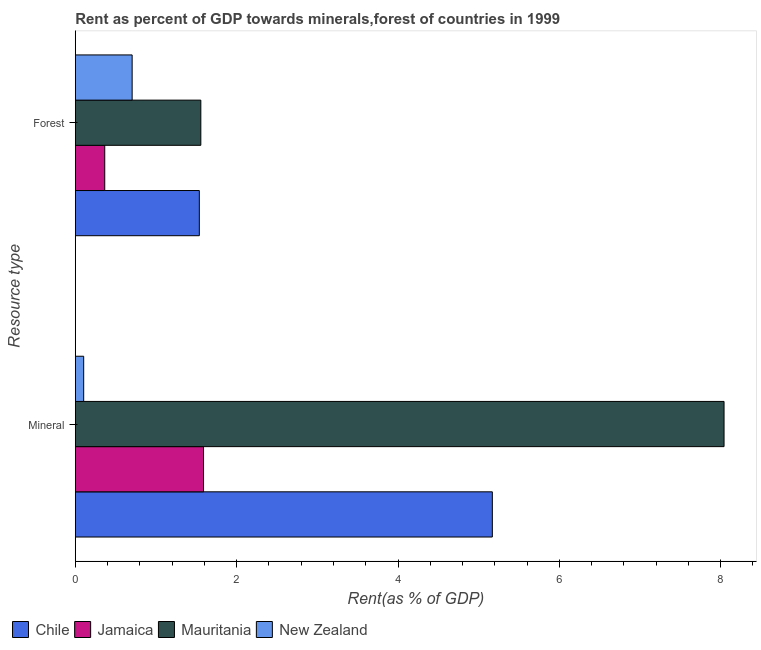How many different coloured bars are there?
Offer a very short reply. 4. How many groups of bars are there?
Give a very brief answer. 2. How many bars are there on the 1st tick from the top?
Provide a short and direct response. 4. How many bars are there on the 1st tick from the bottom?
Give a very brief answer. 4. What is the label of the 1st group of bars from the top?
Ensure brevity in your answer.  Forest. What is the mineral rent in Jamaica?
Offer a very short reply. 1.59. Across all countries, what is the maximum forest rent?
Your answer should be very brief. 1.56. Across all countries, what is the minimum forest rent?
Keep it short and to the point. 0.37. In which country was the forest rent maximum?
Offer a very short reply. Mauritania. In which country was the forest rent minimum?
Give a very brief answer. Jamaica. What is the total mineral rent in the graph?
Your answer should be very brief. 14.9. What is the difference between the forest rent in Mauritania and that in New Zealand?
Your answer should be compact. 0.85. What is the difference between the forest rent in Mauritania and the mineral rent in Jamaica?
Your response must be concise. -0.03. What is the average forest rent per country?
Provide a short and direct response. 1.04. What is the difference between the forest rent and mineral rent in Jamaica?
Give a very brief answer. -1.22. In how many countries, is the mineral rent greater than 0.4 %?
Your answer should be very brief. 3. What is the ratio of the forest rent in Chile to that in Mauritania?
Offer a very short reply. 0.99. In how many countries, is the forest rent greater than the average forest rent taken over all countries?
Offer a terse response. 2. What does the 2nd bar from the top in Mineral represents?
Provide a short and direct response. Mauritania. What does the 3rd bar from the bottom in Mineral represents?
Give a very brief answer. Mauritania. What is the difference between two consecutive major ticks on the X-axis?
Provide a short and direct response. 2. Does the graph contain any zero values?
Your answer should be compact. No. What is the title of the graph?
Keep it short and to the point. Rent as percent of GDP towards minerals,forest of countries in 1999. What is the label or title of the X-axis?
Offer a terse response. Rent(as % of GDP). What is the label or title of the Y-axis?
Offer a terse response. Resource type. What is the Rent(as % of GDP) in Chile in Mineral?
Ensure brevity in your answer.  5.17. What is the Rent(as % of GDP) of Jamaica in Mineral?
Provide a succinct answer. 1.59. What is the Rent(as % of GDP) of Mauritania in Mineral?
Offer a terse response. 8.04. What is the Rent(as % of GDP) in New Zealand in Mineral?
Make the answer very short. 0.1. What is the Rent(as % of GDP) of Chile in Forest?
Offer a terse response. 1.54. What is the Rent(as % of GDP) of Jamaica in Forest?
Your response must be concise. 0.37. What is the Rent(as % of GDP) in Mauritania in Forest?
Provide a short and direct response. 1.56. What is the Rent(as % of GDP) of New Zealand in Forest?
Offer a very short reply. 0.7. Across all Resource type, what is the maximum Rent(as % of GDP) of Chile?
Offer a very short reply. 5.17. Across all Resource type, what is the maximum Rent(as % of GDP) of Jamaica?
Offer a very short reply. 1.59. Across all Resource type, what is the maximum Rent(as % of GDP) of Mauritania?
Your answer should be compact. 8.04. Across all Resource type, what is the maximum Rent(as % of GDP) of New Zealand?
Keep it short and to the point. 0.7. Across all Resource type, what is the minimum Rent(as % of GDP) in Chile?
Offer a terse response. 1.54. Across all Resource type, what is the minimum Rent(as % of GDP) of Jamaica?
Offer a terse response. 0.37. Across all Resource type, what is the minimum Rent(as % of GDP) in Mauritania?
Provide a succinct answer. 1.56. Across all Resource type, what is the minimum Rent(as % of GDP) in New Zealand?
Offer a very short reply. 0.1. What is the total Rent(as % of GDP) of Chile in the graph?
Provide a succinct answer. 6.71. What is the total Rent(as % of GDP) of Jamaica in the graph?
Offer a very short reply. 1.95. What is the total Rent(as % of GDP) of Mauritania in the graph?
Your answer should be compact. 9.6. What is the total Rent(as % of GDP) of New Zealand in the graph?
Provide a succinct answer. 0.81. What is the difference between the Rent(as % of GDP) of Chile in Mineral and that in Forest?
Keep it short and to the point. 3.63. What is the difference between the Rent(as % of GDP) in Jamaica in Mineral and that in Forest?
Give a very brief answer. 1.22. What is the difference between the Rent(as % of GDP) of Mauritania in Mineral and that in Forest?
Provide a short and direct response. 6.49. What is the difference between the Rent(as % of GDP) in New Zealand in Mineral and that in Forest?
Your answer should be compact. -0.6. What is the difference between the Rent(as % of GDP) in Chile in Mineral and the Rent(as % of GDP) in Jamaica in Forest?
Offer a very short reply. 4.8. What is the difference between the Rent(as % of GDP) in Chile in Mineral and the Rent(as % of GDP) in Mauritania in Forest?
Your answer should be very brief. 3.61. What is the difference between the Rent(as % of GDP) of Chile in Mineral and the Rent(as % of GDP) of New Zealand in Forest?
Your response must be concise. 4.46. What is the difference between the Rent(as % of GDP) in Jamaica in Mineral and the Rent(as % of GDP) in Mauritania in Forest?
Your response must be concise. 0.03. What is the difference between the Rent(as % of GDP) of Jamaica in Mineral and the Rent(as % of GDP) of New Zealand in Forest?
Offer a very short reply. 0.89. What is the difference between the Rent(as % of GDP) of Mauritania in Mineral and the Rent(as % of GDP) of New Zealand in Forest?
Make the answer very short. 7.34. What is the average Rent(as % of GDP) of Chile per Resource type?
Keep it short and to the point. 3.35. What is the average Rent(as % of GDP) of Jamaica per Resource type?
Your answer should be very brief. 0.98. What is the average Rent(as % of GDP) in Mauritania per Resource type?
Your answer should be compact. 4.8. What is the average Rent(as % of GDP) of New Zealand per Resource type?
Your answer should be compact. 0.4. What is the difference between the Rent(as % of GDP) in Chile and Rent(as % of GDP) in Jamaica in Mineral?
Offer a very short reply. 3.58. What is the difference between the Rent(as % of GDP) in Chile and Rent(as % of GDP) in Mauritania in Mineral?
Provide a succinct answer. -2.87. What is the difference between the Rent(as % of GDP) of Chile and Rent(as % of GDP) of New Zealand in Mineral?
Keep it short and to the point. 5.07. What is the difference between the Rent(as % of GDP) of Jamaica and Rent(as % of GDP) of Mauritania in Mineral?
Keep it short and to the point. -6.45. What is the difference between the Rent(as % of GDP) in Jamaica and Rent(as % of GDP) in New Zealand in Mineral?
Offer a terse response. 1.49. What is the difference between the Rent(as % of GDP) of Mauritania and Rent(as % of GDP) of New Zealand in Mineral?
Give a very brief answer. 7.94. What is the difference between the Rent(as % of GDP) of Chile and Rent(as % of GDP) of Jamaica in Forest?
Ensure brevity in your answer.  1.17. What is the difference between the Rent(as % of GDP) in Chile and Rent(as % of GDP) in Mauritania in Forest?
Your answer should be very brief. -0.02. What is the difference between the Rent(as % of GDP) of Chile and Rent(as % of GDP) of New Zealand in Forest?
Your response must be concise. 0.83. What is the difference between the Rent(as % of GDP) of Jamaica and Rent(as % of GDP) of Mauritania in Forest?
Ensure brevity in your answer.  -1.19. What is the difference between the Rent(as % of GDP) of Jamaica and Rent(as % of GDP) of New Zealand in Forest?
Your answer should be very brief. -0.34. What is the difference between the Rent(as % of GDP) in Mauritania and Rent(as % of GDP) in New Zealand in Forest?
Ensure brevity in your answer.  0.85. What is the ratio of the Rent(as % of GDP) in Chile in Mineral to that in Forest?
Offer a terse response. 3.36. What is the ratio of the Rent(as % of GDP) of Jamaica in Mineral to that in Forest?
Provide a succinct answer. 4.35. What is the ratio of the Rent(as % of GDP) of Mauritania in Mineral to that in Forest?
Give a very brief answer. 5.17. What is the ratio of the Rent(as % of GDP) of New Zealand in Mineral to that in Forest?
Provide a short and direct response. 0.15. What is the difference between the highest and the second highest Rent(as % of GDP) in Chile?
Provide a short and direct response. 3.63. What is the difference between the highest and the second highest Rent(as % of GDP) of Jamaica?
Ensure brevity in your answer.  1.22. What is the difference between the highest and the second highest Rent(as % of GDP) in Mauritania?
Your answer should be very brief. 6.49. What is the difference between the highest and the second highest Rent(as % of GDP) in New Zealand?
Make the answer very short. 0.6. What is the difference between the highest and the lowest Rent(as % of GDP) of Chile?
Make the answer very short. 3.63. What is the difference between the highest and the lowest Rent(as % of GDP) in Jamaica?
Give a very brief answer. 1.22. What is the difference between the highest and the lowest Rent(as % of GDP) in Mauritania?
Provide a succinct answer. 6.49. What is the difference between the highest and the lowest Rent(as % of GDP) of New Zealand?
Your answer should be very brief. 0.6. 